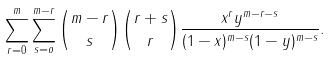Convert formula to latex. <formula><loc_0><loc_0><loc_500><loc_500>\sum _ { r = 0 } ^ { m } \sum _ { s = o } ^ { m - r } { m - r \choose s } { r + s \choose r } \frac { x ^ { r } y ^ { m - r - s } } { ( 1 - x ) ^ { m - s } ( 1 - y ) ^ { m - s } } .</formula> 